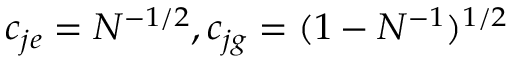<formula> <loc_0><loc_0><loc_500><loc_500>c _ { j e } = N ^ { - 1 / 2 } , c _ { j g } = ( 1 - N ^ { - 1 } ) ^ { 1 / 2 }</formula> 